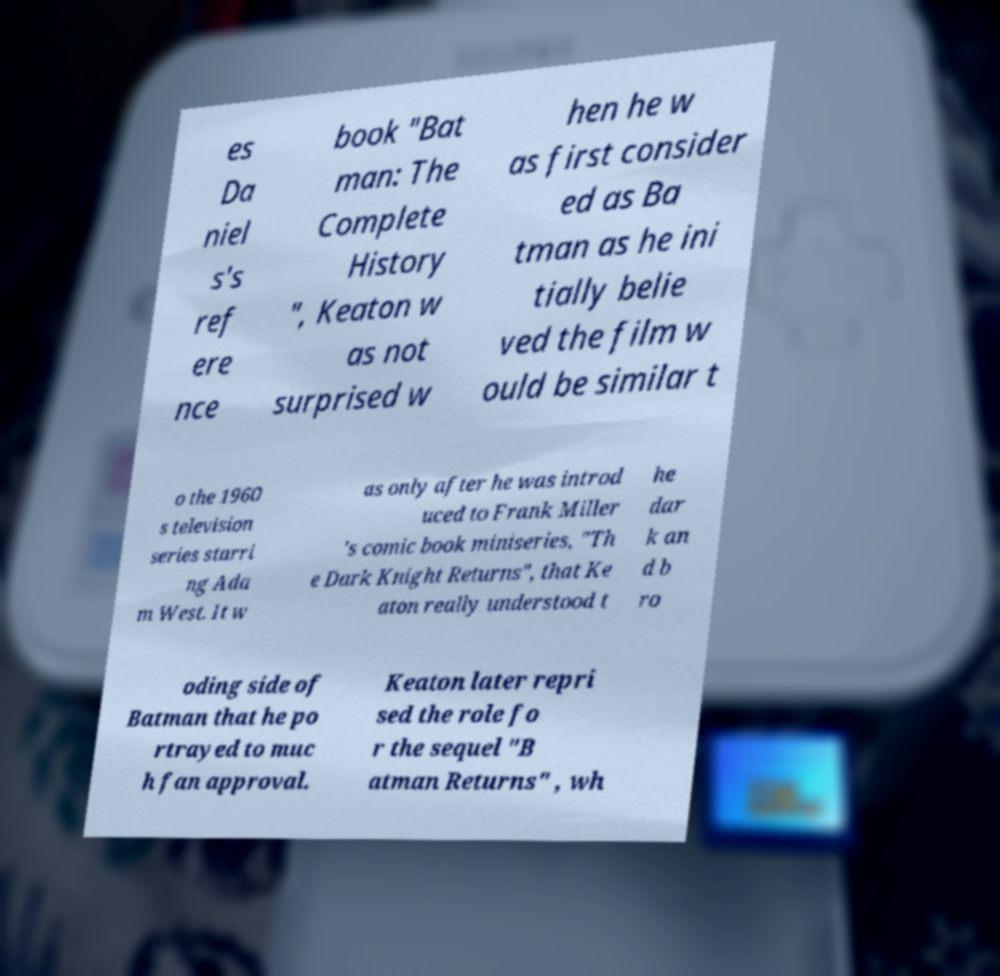Can you accurately transcribe the text from the provided image for me? es Da niel s's ref ere nce book "Bat man: The Complete History ", Keaton w as not surprised w hen he w as first consider ed as Ba tman as he ini tially belie ved the film w ould be similar t o the 1960 s television series starri ng Ada m West. It w as only after he was introd uced to Frank Miller 's comic book miniseries, "Th e Dark Knight Returns", that Ke aton really understood t he dar k an d b ro oding side of Batman that he po rtrayed to muc h fan approval. Keaton later repri sed the role fo r the sequel "B atman Returns" , wh 